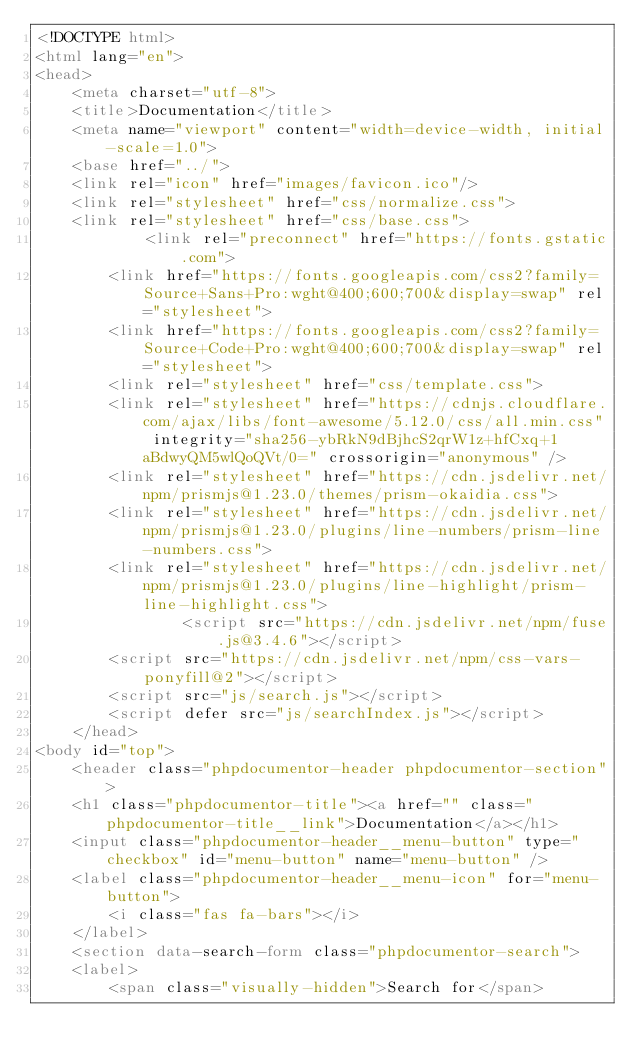<code> <loc_0><loc_0><loc_500><loc_500><_HTML_><!DOCTYPE html>
<html lang="en">
<head>
    <meta charset="utf-8">
    <title>Documentation</title>
    <meta name="viewport" content="width=device-width, initial-scale=1.0">
    <base href="../">
    <link rel="icon" href="images/favicon.ico"/>
    <link rel="stylesheet" href="css/normalize.css">
    <link rel="stylesheet" href="css/base.css">
            <link rel="preconnect" href="https://fonts.gstatic.com">
        <link href="https://fonts.googleapis.com/css2?family=Source+Sans+Pro:wght@400;600;700&display=swap" rel="stylesheet">
        <link href="https://fonts.googleapis.com/css2?family=Source+Code+Pro:wght@400;600;700&display=swap" rel="stylesheet">
        <link rel="stylesheet" href="css/template.css">
        <link rel="stylesheet" href="https://cdnjs.cloudflare.com/ajax/libs/font-awesome/5.12.0/css/all.min.css" integrity="sha256-ybRkN9dBjhcS2qrW1z+hfCxq+1aBdwyQM5wlQoQVt/0=" crossorigin="anonymous" />
        <link rel="stylesheet" href="https://cdn.jsdelivr.net/npm/prismjs@1.23.0/themes/prism-okaidia.css">
        <link rel="stylesheet" href="https://cdn.jsdelivr.net/npm/prismjs@1.23.0/plugins/line-numbers/prism-line-numbers.css">
        <link rel="stylesheet" href="https://cdn.jsdelivr.net/npm/prismjs@1.23.0/plugins/line-highlight/prism-line-highlight.css">
                <script src="https://cdn.jsdelivr.net/npm/fuse.js@3.4.6"></script>
        <script src="https://cdn.jsdelivr.net/npm/css-vars-ponyfill@2"></script>
        <script src="js/search.js"></script>
        <script defer src="js/searchIndex.js"></script>
    </head>
<body id="top">
    <header class="phpdocumentor-header phpdocumentor-section">
    <h1 class="phpdocumentor-title"><a href="" class="phpdocumentor-title__link">Documentation</a></h1>
    <input class="phpdocumentor-header__menu-button" type="checkbox" id="menu-button" name="menu-button" />
    <label class="phpdocumentor-header__menu-icon" for="menu-button">
        <i class="fas fa-bars"></i>
    </label>
    <section data-search-form class="phpdocumentor-search">
    <label>
        <span class="visually-hidden">Search for</span></code> 